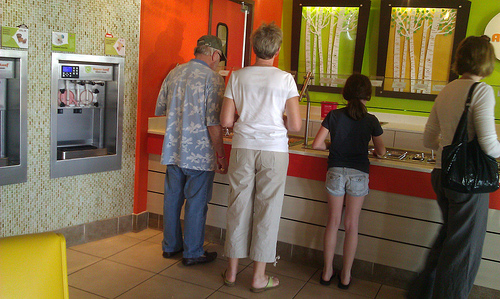<image>
Can you confirm if the uncle is to the right of the small girl? No. The uncle is not to the right of the small girl. The horizontal positioning shows a different relationship. Is the girl to the left of the women? No. The girl is not to the left of the women. From this viewpoint, they have a different horizontal relationship. 